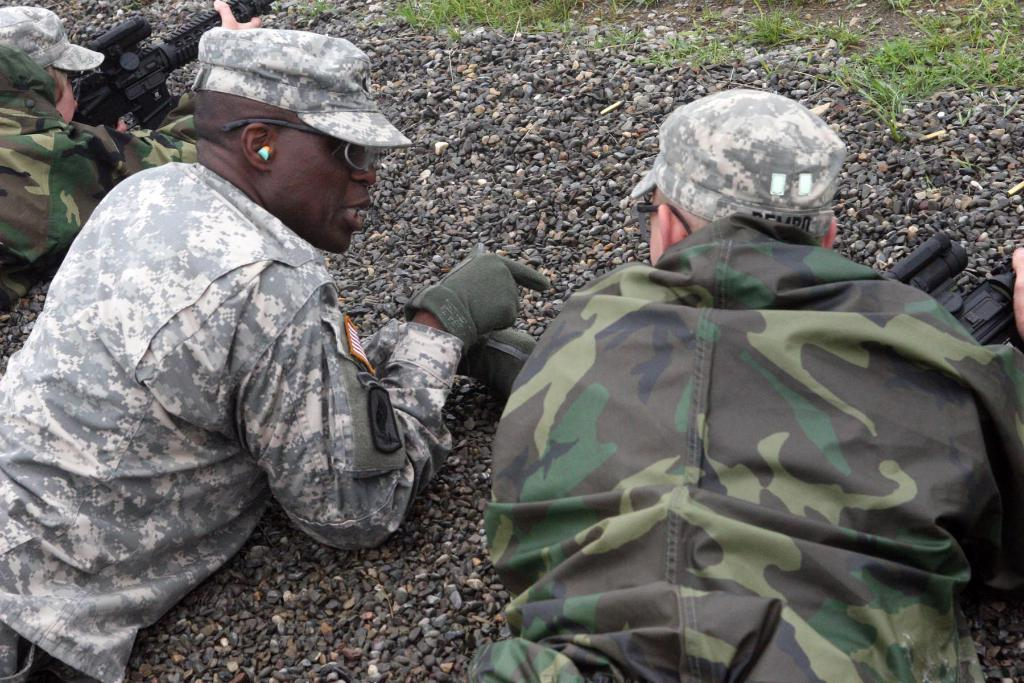How many people are in the image? There are three persons in the image. What are the persons doing in the image? The persons are lying on stones. What accessories are the persons wearing? The persons are wearing caps and goggles. What are two of the persons holding in the image? Two of the persons are holding guns. What type of ground surface is visible in the image? There is grass on the ground in the image. Can you see a clam crawling on the grass in the image? There is no clam present in the image; it features three persons lying on stones, wearing caps and goggles, and holding guns. Is there a monkey swinging from a chain in the image? There is no monkey or chain present in the image. 